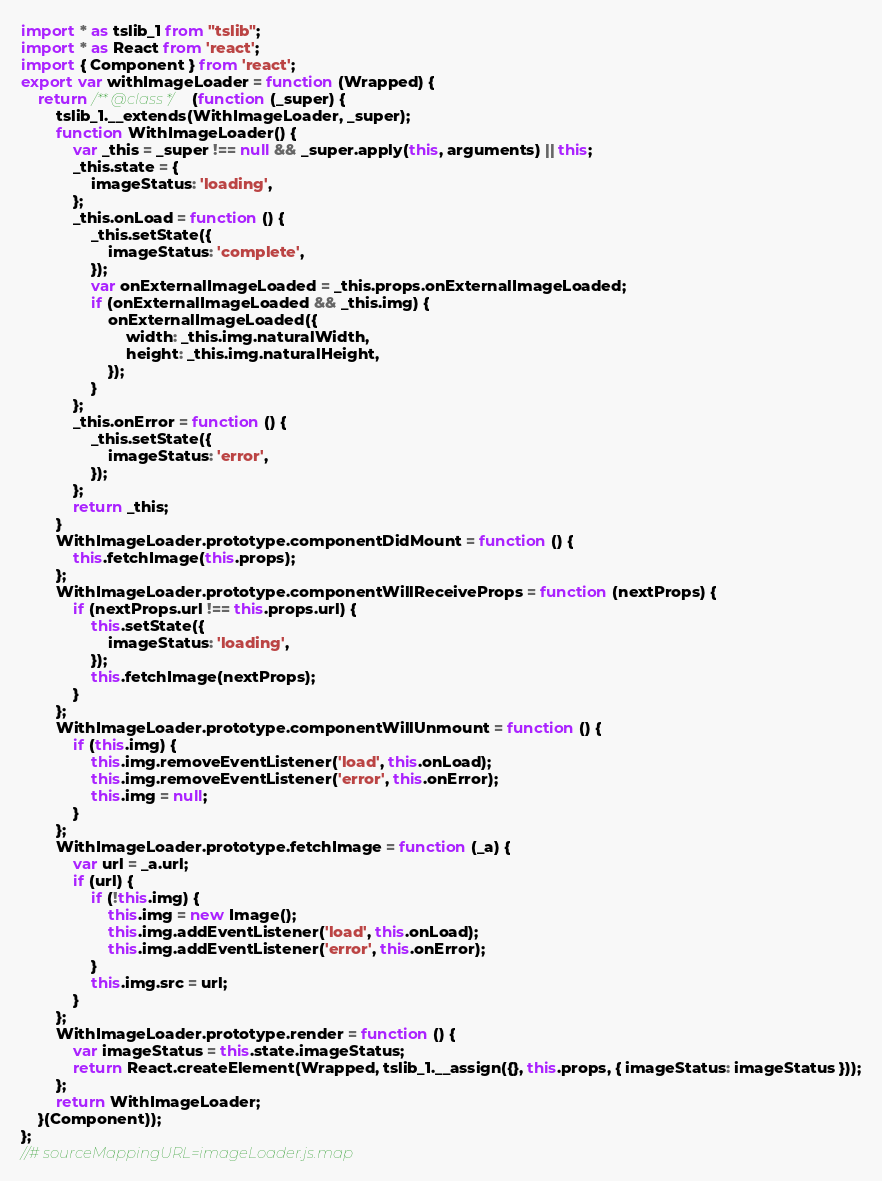Convert code to text. <code><loc_0><loc_0><loc_500><loc_500><_JavaScript_>import * as tslib_1 from "tslib";
import * as React from 'react';
import { Component } from 'react';
export var withImageLoader = function (Wrapped) {
    return /** @class */ (function (_super) {
        tslib_1.__extends(WithImageLoader, _super);
        function WithImageLoader() {
            var _this = _super !== null && _super.apply(this, arguments) || this;
            _this.state = {
                imageStatus: 'loading',
            };
            _this.onLoad = function () {
                _this.setState({
                    imageStatus: 'complete',
                });
                var onExternalImageLoaded = _this.props.onExternalImageLoaded;
                if (onExternalImageLoaded && _this.img) {
                    onExternalImageLoaded({
                        width: _this.img.naturalWidth,
                        height: _this.img.naturalHeight,
                    });
                }
            };
            _this.onError = function () {
                _this.setState({
                    imageStatus: 'error',
                });
            };
            return _this;
        }
        WithImageLoader.prototype.componentDidMount = function () {
            this.fetchImage(this.props);
        };
        WithImageLoader.prototype.componentWillReceiveProps = function (nextProps) {
            if (nextProps.url !== this.props.url) {
                this.setState({
                    imageStatus: 'loading',
                });
                this.fetchImage(nextProps);
            }
        };
        WithImageLoader.prototype.componentWillUnmount = function () {
            if (this.img) {
                this.img.removeEventListener('load', this.onLoad);
                this.img.removeEventListener('error', this.onError);
                this.img = null;
            }
        };
        WithImageLoader.prototype.fetchImage = function (_a) {
            var url = _a.url;
            if (url) {
                if (!this.img) {
                    this.img = new Image();
                    this.img.addEventListener('load', this.onLoad);
                    this.img.addEventListener('error', this.onError);
                }
                this.img.src = url;
            }
        };
        WithImageLoader.prototype.render = function () {
            var imageStatus = this.state.imageStatus;
            return React.createElement(Wrapped, tslib_1.__assign({}, this.props, { imageStatus: imageStatus }));
        };
        return WithImageLoader;
    }(Component));
};
//# sourceMappingURL=imageLoader.js.map</code> 